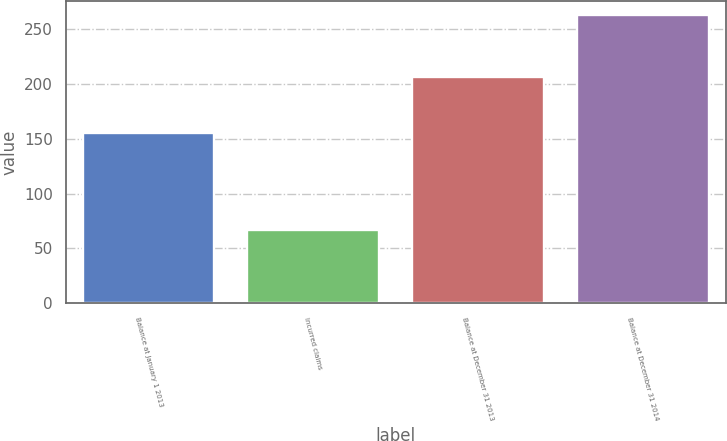<chart> <loc_0><loc_0><loc_500><loc_500><bar_chart><fcel>Balance at January 1 2013<fcel>Incurred claims<fcel>Balance at December 31 2013<fcel>Balance at December 31 2014<nl><fcel>155<fcel>67<fcel>206<fcel>263<nl></chart> 